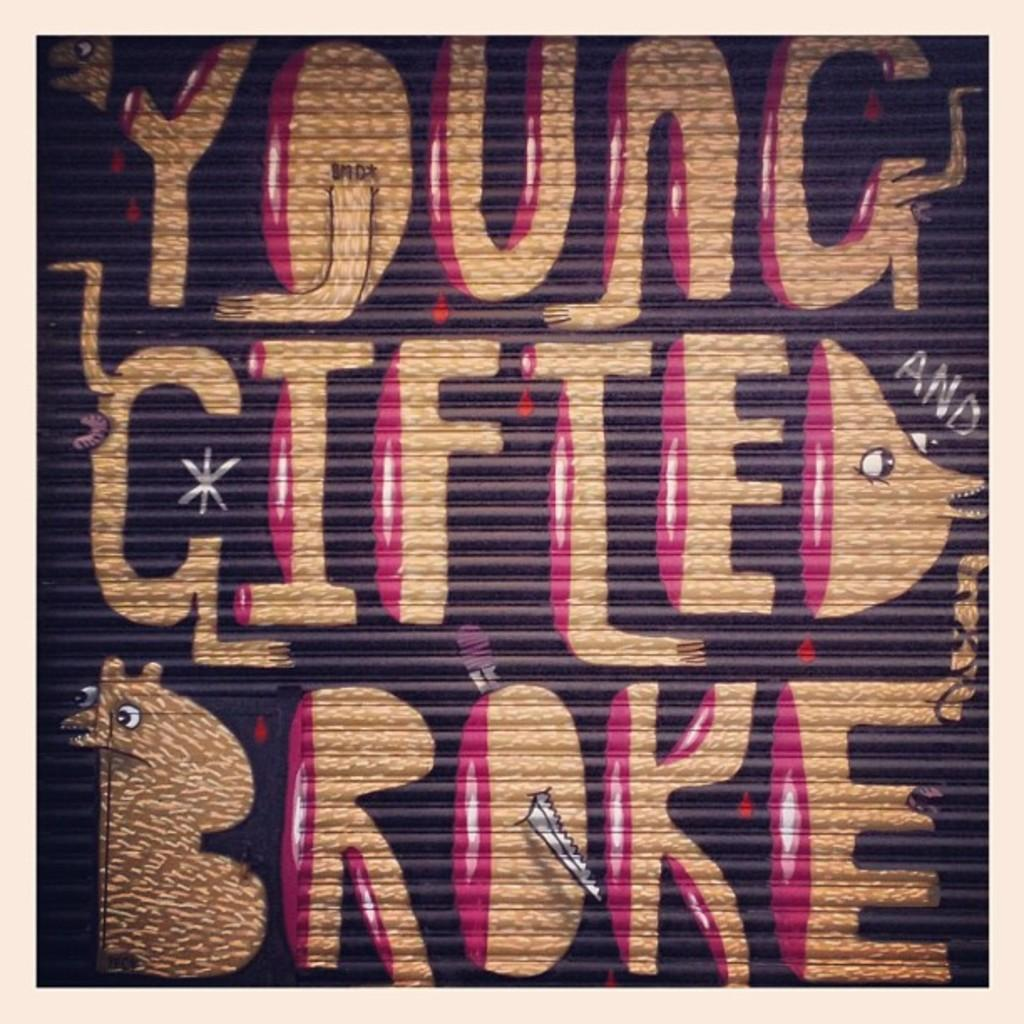<image>
Render a clear and concise summary of the photo. A graffiti saying "YOUNG GIFTED BROKE" is painted in gold and purple on the retractable door. 